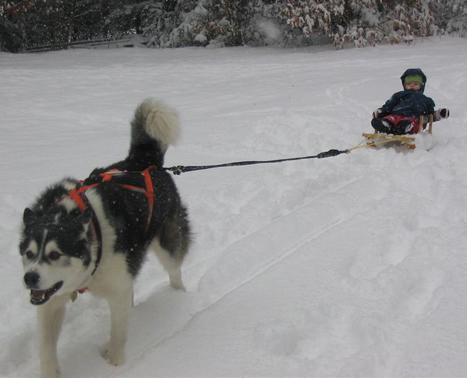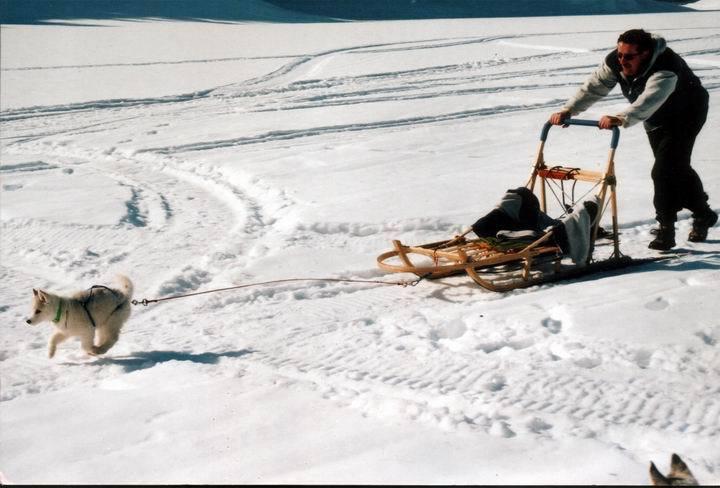The first image is the image on the left, the second image is the image on the right. Evaluate the accuracy of this statement regarding the images: "An image includes a child in a dark jacket leaning forward as he pulls a sled carrying one upright sitting husky on it across the snow.". Is it true? Answer yes or no. No. 